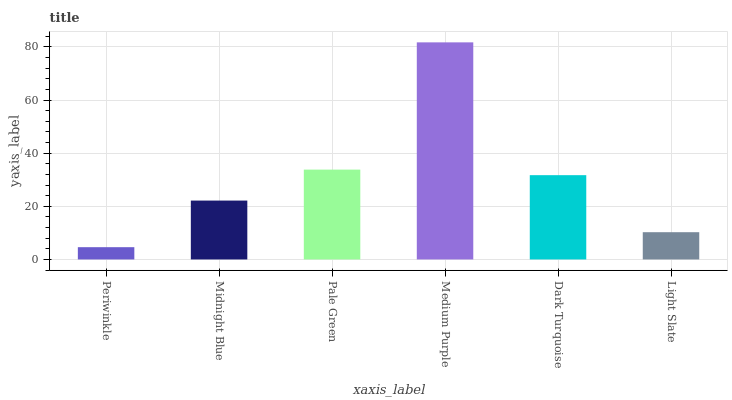Is Periwinkle the minimum?
Answer yes or no. Yes. Is Medium Purple the maximum?
Answer yes or no. Yes. Is Midnight Blue the minimum?
Answer yes or no. No. Is Midnight Blue the maximum?
Answer yes or no. No. Is Midnight Blue greater than Periwinkle?
Answer yes or no. Yes. Is Periwinkle less than Midnight Blue?
Answer yes or no. Yes. Is Periwinkle greater than Midnight Blue?
Answer yes or no. No. Is Midnight Blue less than Periwinkle?
Answer yes or no. No. Is Dark Turquoise the high median?
Answer yes or no. Yes. Is Midnight Blue the low median?
Answer yes or no. Yes. Is Midnight Blue the high median?
Answer yes or no. No. Is Pale Green the low median?
Answer yes or no. No. 